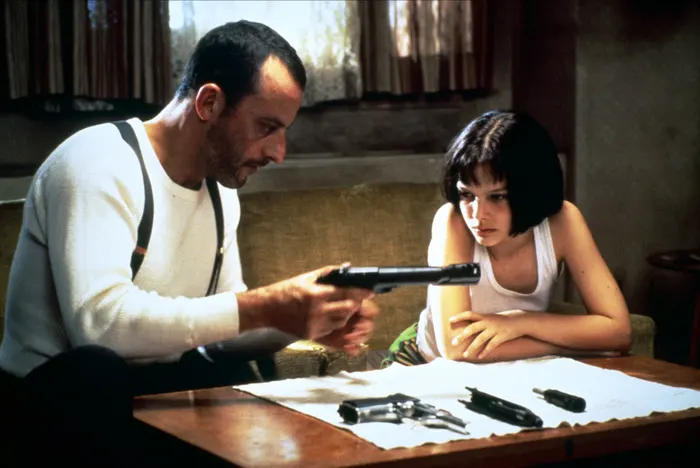Explain the visual content of the image in great detail. In this image, we see a scene from the movie "Léon: The Professional". The focus is on two characters, Léon, played by Jean Reno, and Mathilda, played by Natalie Portman. They are both seated at a wooden table. Léon is wearing a white tank top and has a black gun in his hand. He is pointing the gun at a piece of paper on the table. Mathilda, who is sitting next to him, is also dressed in a white tank top and is wearing a black choker necklace. She is looking at the piece of paper with a concerned expression. The table is scattered with several other guns. The background features a beige wall with a window and a plant, adding to the overall ambiance of the scene. 